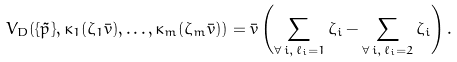<formula> <loc_0><loc_0><loc_500><loc_500>V _ { D } ( \{ \tilde { p } \} , \kappa _ { 1 } ( \zeta _ { 1 } \bar { v } ) , \dots , \kappa _ { m } ( \zeta _ { m } \bar { v } ) ) = \bar { v } \left ( \sum _ { \forall \, i , \, \ell _ { i } = 1 } \zeta _ { i } - \sum _ { \forall \, i , \, \ell _ { i } = 2 } \zeta _ { i } \right ) .</formula> 